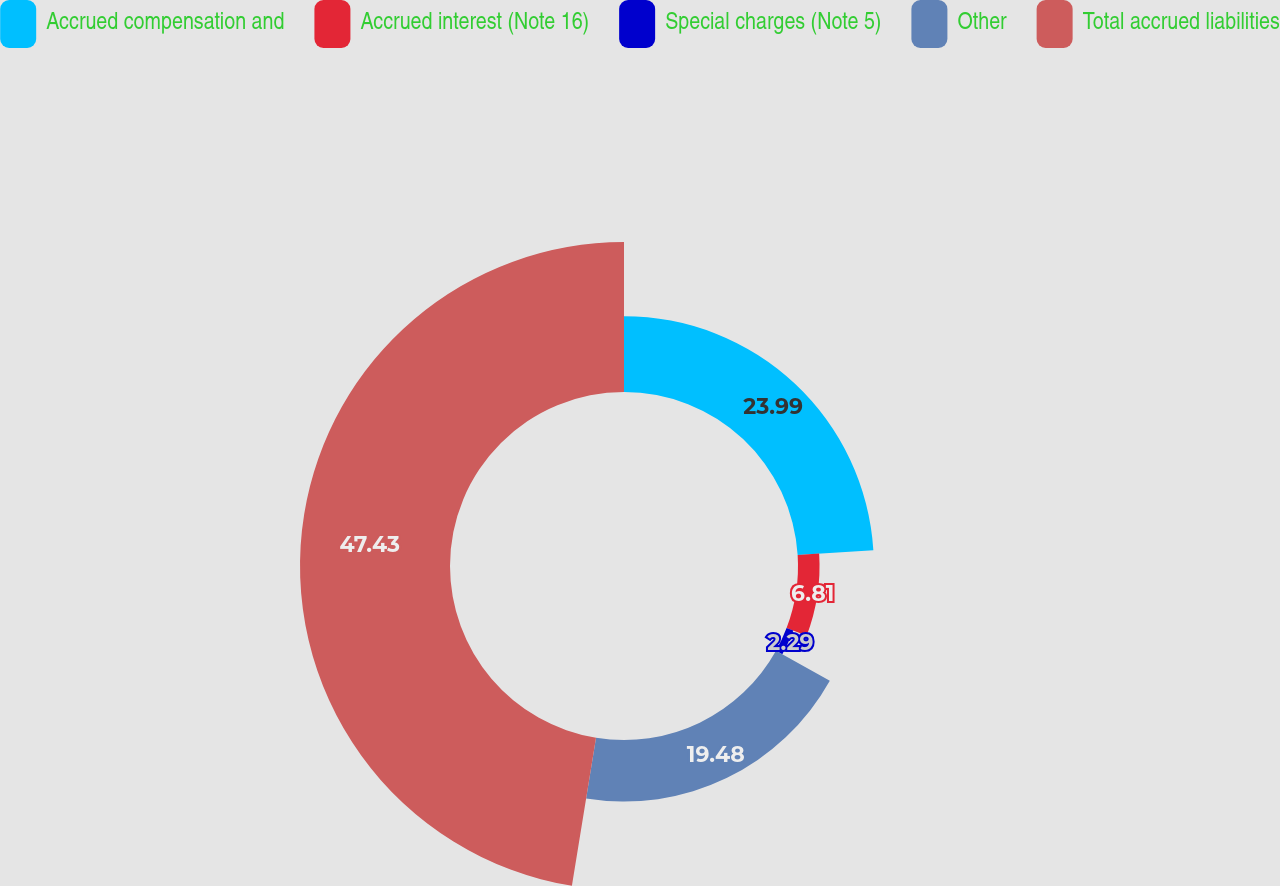Convert chart to OTSL. <chart><loc_0><loc_0><loc_500><loc_500><pie_chart><fcel>Accrued compensation and<fcel>Accrued interest (Note 16)<fcel>Special charges (Note 5)<fcel>Other<fcel>Total accrued liabilities<nl><fcel>23.99%<fcel>6.81%<fcel>2.29%<fcel>19.48%<fcel>47.43%<nl></chart> 